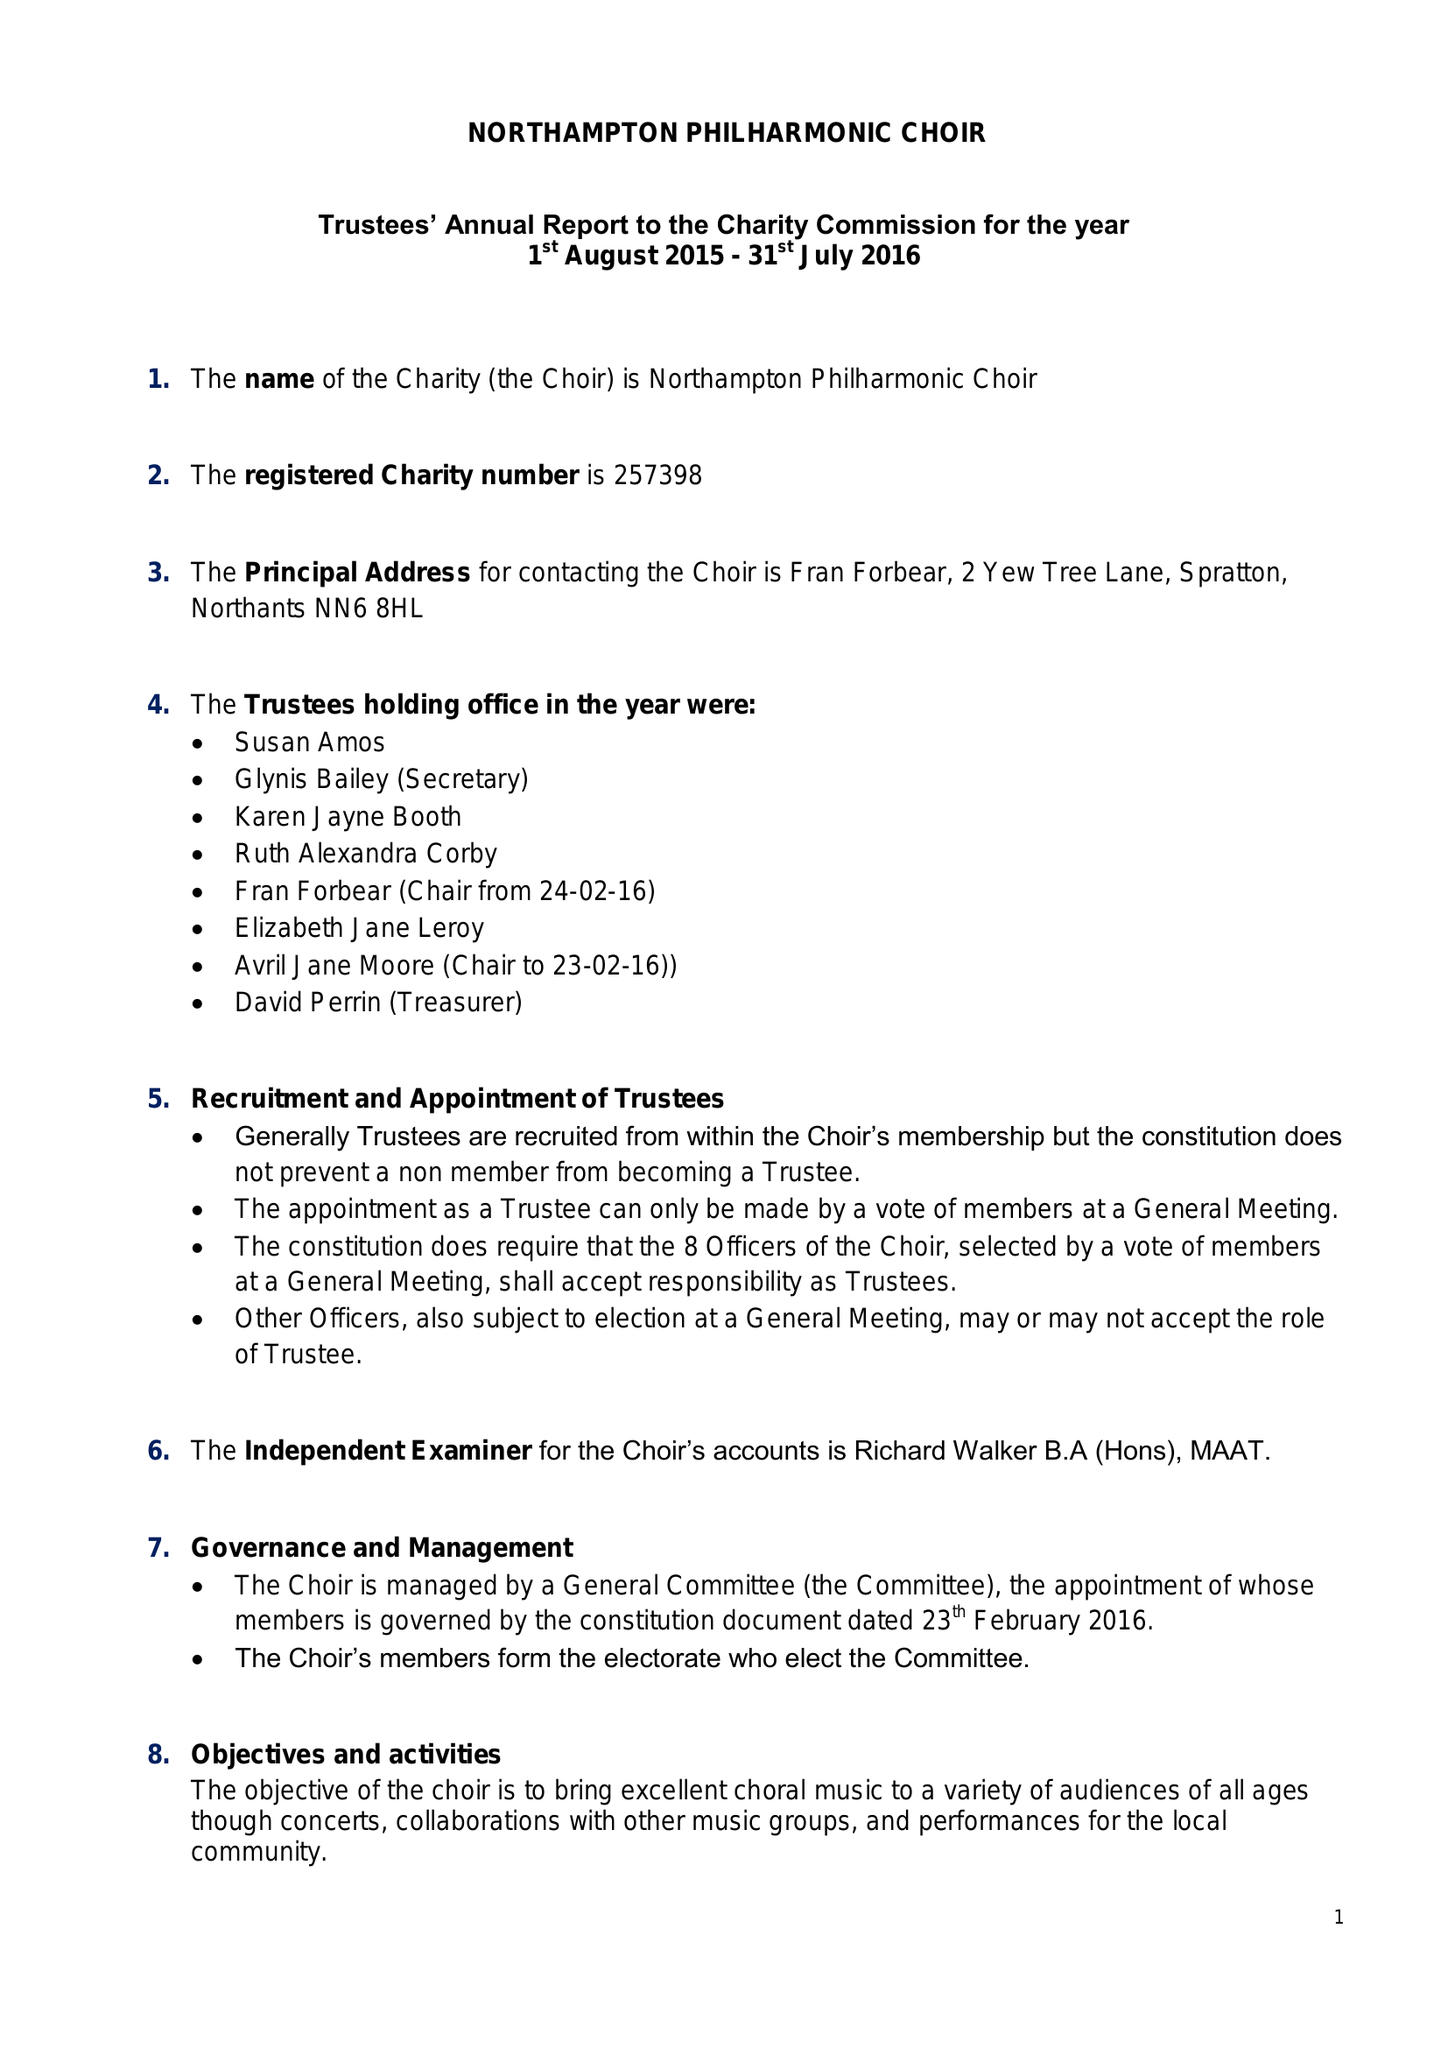What is the value for the charity_number?
Answer the question using a single word or phrase. 257398 